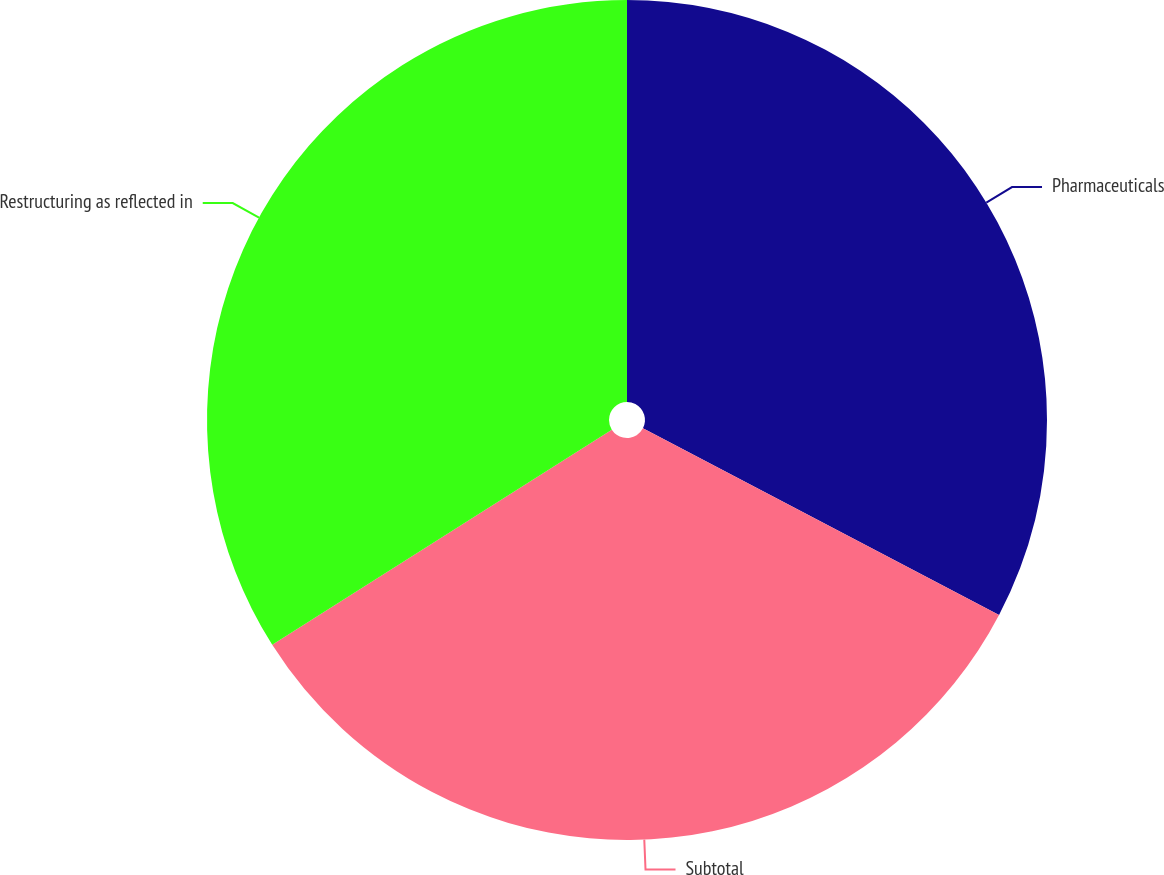<chart> <loc_0><loc_0><loc_500><loc_500><pie_chart><fcel>Pharmaceuticals<fcel>Subtotal<fcel>Restructuring as reflected in<nl><fcel>32.68%<fcel>33.33%<fcel>33.99%<nl></chart> 